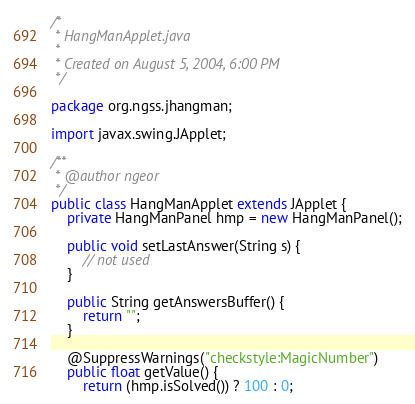Convert code to text. <code><loc_0><loc_0><loc_500><loc_500><_Java_>/*
 * HangManApplet.java
 *
 * Created on August 5, 2004, 6:00 PM
 */

package org.ngss.jhangman;

import javax.swing.JApplet;

/**
 * @author ngeor
 */
public class HangManApplet extends JApplet {
    private HangManPanel hmp = new HangManPanel();

    public void setLastAnswer(String s) {
        // not used
    }

    public String getAnswersBuffer() {
        return "";
    }

    @SuppressWarnings("checkstyle:MagicNumber")
    public float getValue() {
        return (hmp.isSolved()) ? 100 : 0;</code> 